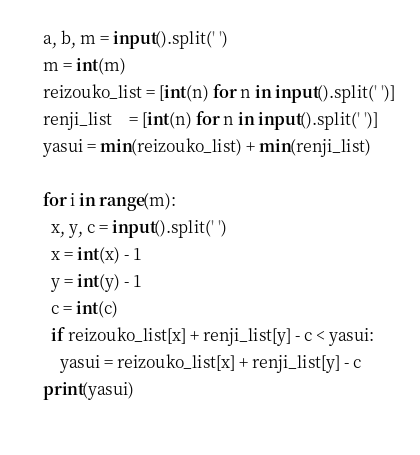Convert code to text. <code><loc_0><loc_0><loc_500><loc_500><_Python_>a, b, m = input().split(' ')
m = int(m)
reizouko_list = [int(n) for n in input().split(' ')]
renji_list    = [int(n) for n in input().split(' ')]
yasui = min(reizouko_list) + min(renji_list)

for i in range(m):
  x, y, c = input().split(' ')
  x = int(x) - 1
  y = int(y) - 1
  c = int(c)
  if reizouko_list[x] + renji_list[y] - c < yasui:
    yasui = reizouko_list[x] + renji_list[y] - c
print(yasui)
  </code> 